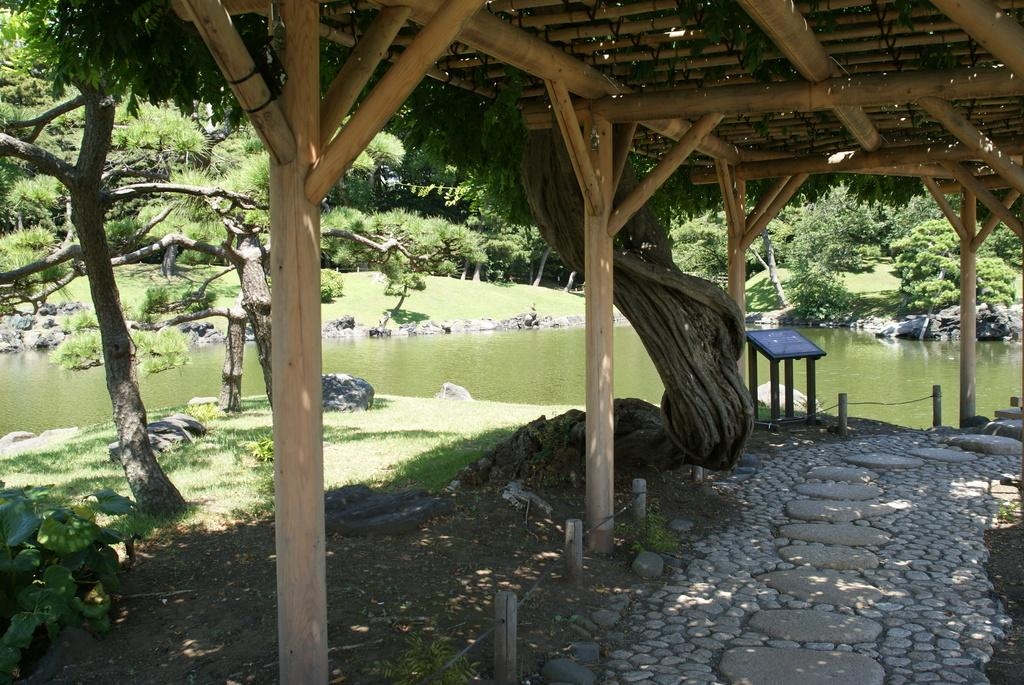What is located in the foreground of the image? There is a shelter in the foreground of the image. What can be seen in the background of the image? There are trees, stones, and a water body in the background of the image. Can you describe the table in the image? There is a table in the image, but its specific features are not mentioned in the facts. What type of natural environment is visible in the image? The image features a natural environment with trees, stones, and a water body. What type of underwear is the manager wearing in the image? There is no mention of a manager or underwear in the image, so this question cannot be answered. 